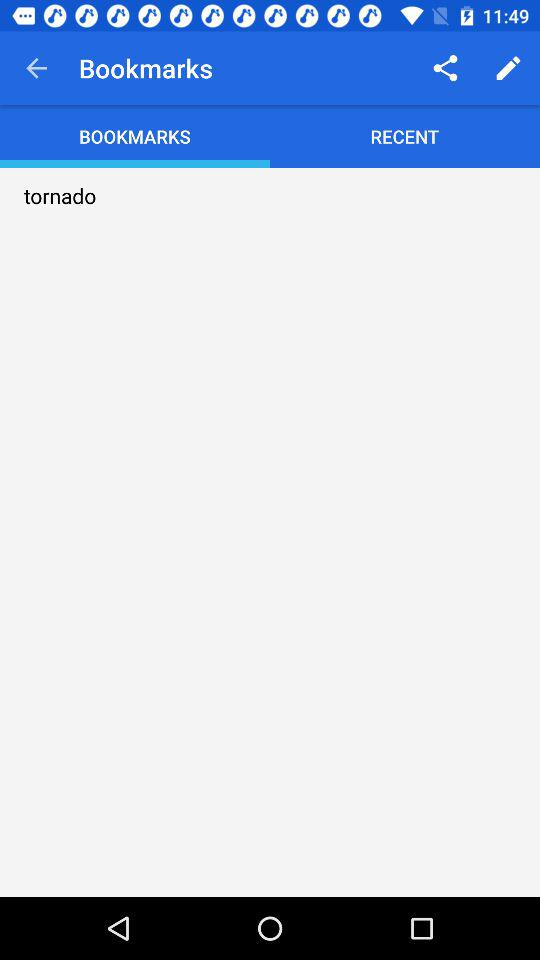Which tab has been selected? The selected tab is "BOOKMARKS". 